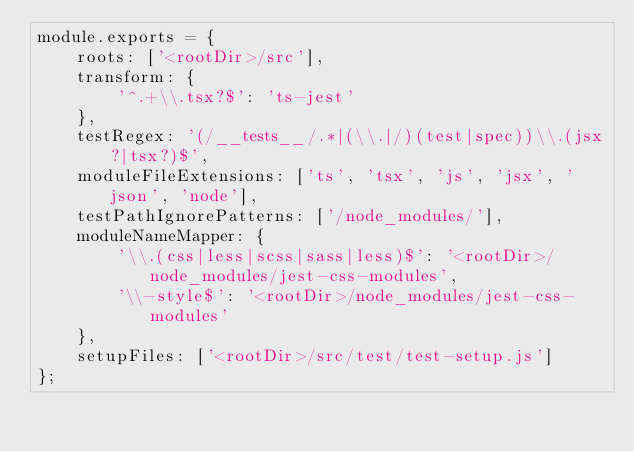Convert code to text. <code><loc_0><loc_0><loc_500><loc_500><_JavaScript_>module.exports = {
	roots: ['<rootDir>/src'],
	transform: {
		'^.+\\.tsx?$': 'ts-jest'
	},
	testRegex: '(/__tests__/.*|(\\.|/)(test|spec))\\.(jsx?|tsx?)$',
	moduleFileExtensions: ['ts', 'tsx', 'js', 'jsx', 'json', 'node'],
	testPathIgnorePatterns: ['/node_modules/'],
	moduleNameMapper: {
		'\\.(css|less|scss|sass|less)$': '<rootDir>/node_modules/jest-css-modules',
		'\\-style$': '<rootDir>/node_modules/jest-css-modules'
	},
	setupFiles: ['<rootDir>/src/test/test-setup.js']
};
</code> 